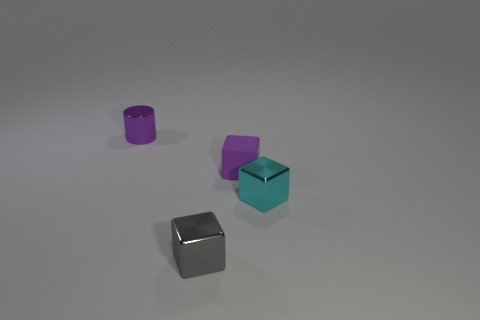There is a tiny object that is left of the gray object; is it the same color as the matte block behind the gray block?
Offer a very short reply. Yes. Are there any objects that have the same color as the cylinder?
Provide a short and direct response. Yes. How many things are either small objects in front of the cyan metallic object or cubes that are in front of the purple cube?
Ensure brevity in your answer.  2. How many other objects are there of the same size as the matte thing?
Provide a short and direct response. 3. Does the small metallic thing that is behind the matte block have the same color as the rubber cube?
Keep it short and to the point. Yes. There is a thing that is both behind the tiny gray shiny object and in front of the rubber object; what size is it?
Make the answer very short. Small. How many big objects are either blue metallic spheres or cylinders?
Offer a terse response. 0. What is the shape of the tiny gray shiny thing to the left of the tiny cyan metal object?
Keep it short and to the point. Cube. How many blue matte balls are there?
Give a very brief answer. 0. Do the tiny cyan block and the small purple cube have the same material?
Offer a terse response. No. 